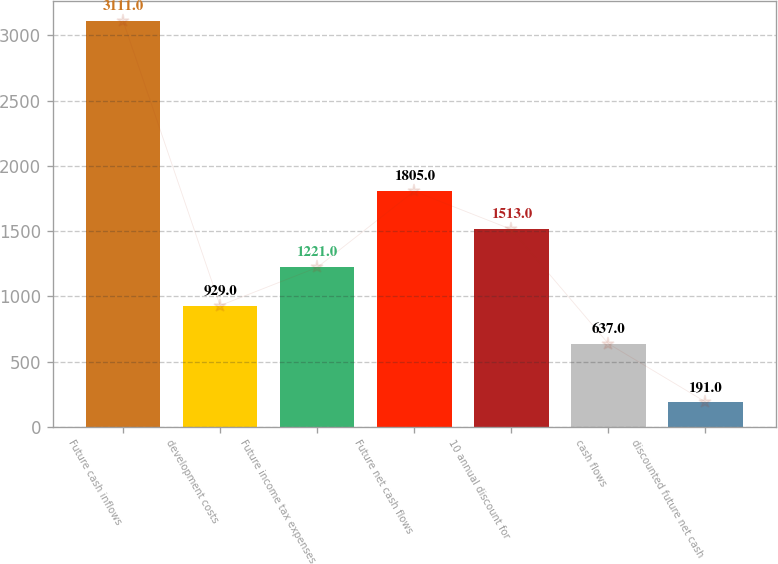Convert chart to OTSL. <chart><loc_0><loc_0><loc_500><loc_500><bar_chart><fcel>Future cash inflows<fcel>development costs<fcel>Future income tax expenses<fcel>Future net cash flows<fcel>10 annual discount for<fcel>cash flows<fcel>discounted future net cash<nl><fcel>3111<fcel>929<fcel>1221<fcel>1805<fcel>1513<fcel>637<fcel>191<nl></chart> 